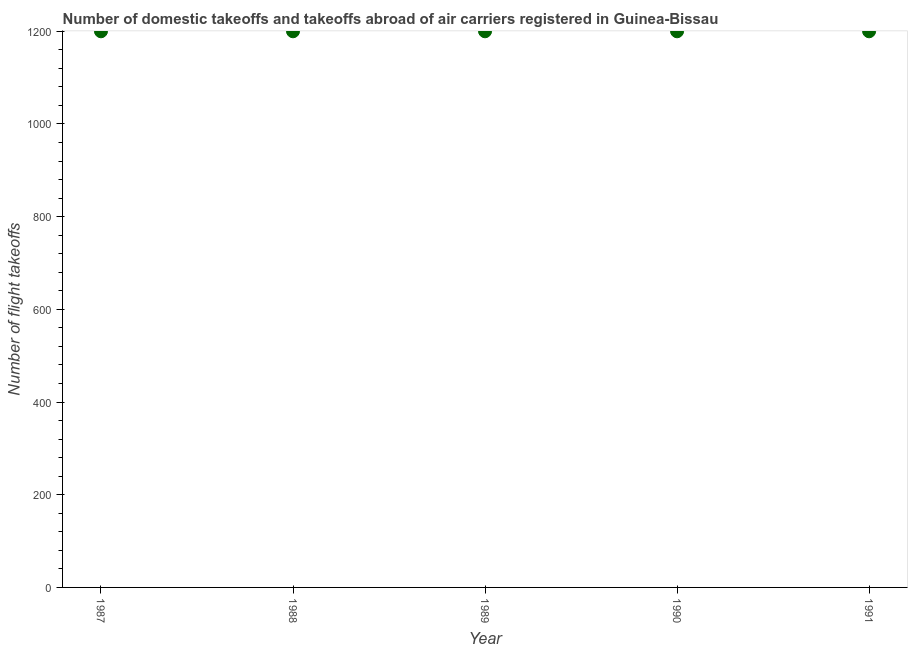What is the number of flight takeoffs in 1988?
Ensure brevity in your answer.  1200. Across all years, what is the maximum number of flight takeoffs?
Keep it short and to the point. 1200. Across all years, what is the minimum number of flight takeoffs?
Offer a terse response. 1200. In which year was the number of flight takeoffs minimum?
Your response must be concise. 1987. What is the sum of the number of flight takeoffs?
Offer a terse response. 6000. What is the average number of flight takeoffs per year?
Ensure brevity in your answer.  1200. What is the median number of flight takeoffs?
Give a very brief answer. 1200. In how many years, is the number of flight takeoffs greater than 960 ?
Offer a terse response. 5. Do a majority of the years between 1990 and 1989 (inclusive) have number of flight takeoffs greater than 440 ?
Keep it short and to the point. No. Is the number of flight takeoffs in 1988 less than that in 1991?
Provide a short and direct response. No. Is the sum of the number of flight takeoffs in 1988 and 1989 greater than the maximum number of flight takeoffs across all years?
Make the answer very short. Yes. In how many years, is the number of flight takeoffs greater than the average number of flight takeoffs taken over all years?
Provide a succinct answer. 0. Does the number of flight takeoffs monotonically increase over the years?
Your answer should be compact. No. What is the difference between two consecutive major ticks on the Y-axis?
Ensure brevity in your answer.  200. What is the title of the graph?
Keep it short and to the point. Number of domestic takeoffs and takeoffs abroad of air carriers registered in Guinea-Bissau. What is the label or title of the X-axis?
Ensure brevity in your answer.  Year. What is the label or title of the Y-axis?
Keep it short and to the point. Number of flight takeoffs. What is the Number of flight takeoffs in 1987?
Provide a succinct answer. 1200. What is the Number of flight takeoffs in 1988?
Your answer should be very brief. 1200. What is the Number of flight takeoffs in 1989?
Give a very brief answer. 1200. What is the Number of flight takeoffs in 1990?
Your answer should be very brief. 1200. What is the Number of flight takeoffs in 1991?
Your response must be concise. 1200. What is the difference between the Number of flight takeoffs in 1987 and 1989?
Keep it short and to the point. 0. What is the difference between the Number of flight takeoffs in 1987 and 1991?
Keep it short and to the point. 0. What is the difference between the Number of flight takeoffs in 1988 and 1989?
Offer a very short reply. 0. What is the difference between the Number of flight takeoffs in 1988 and 1991?
Provide a short and direct response. 0. What is the difference between the Number of flight takeoffs in 1990 and 1991?
Your response must be concise. 0. What is the ratio of the Number of flight takeoffs in 1987 to that in 1991?
Offer a terse response. 1. What is the ratio of the Number of flight takeoffs in 1988 to that in 1991?
Give a very brief answer. 1. What is the ratio of the Number of flight takeoffs in 1990 to that in 1991?
Your answer should be compact. 1. 